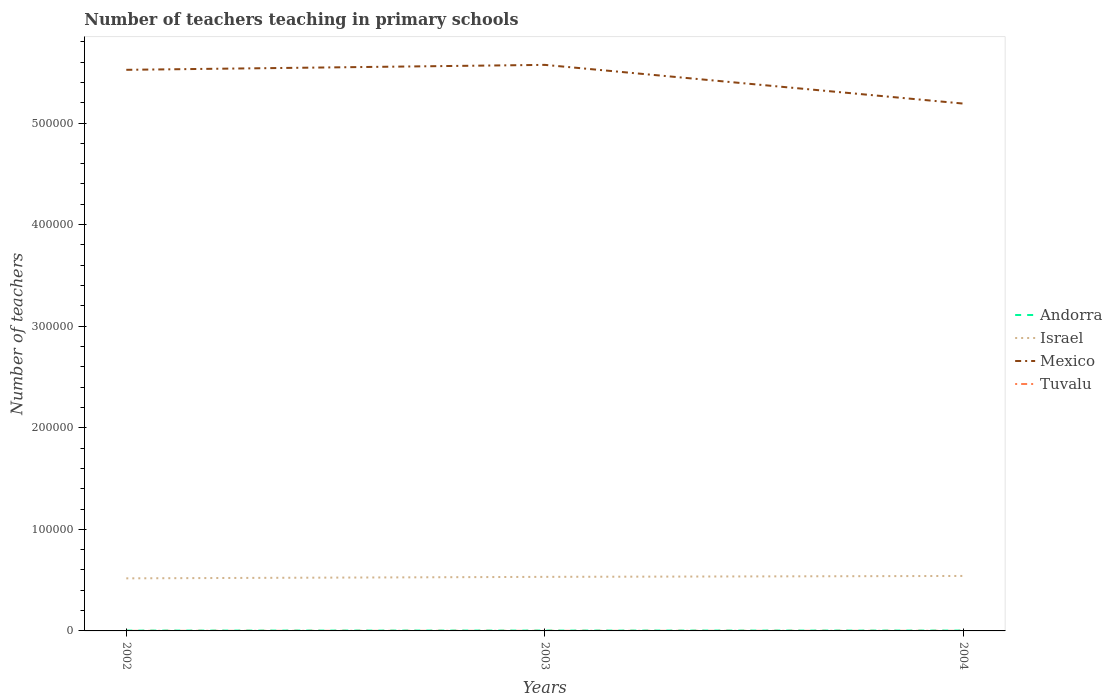How many different coloured lines are there?
Your response must be concise. 4. Is the number of lines equal to the number of legend labels?
Keep it short and to the point. Yes. Across all years, what is the maximum number of teachers teaching in primary schools in Israel?
Ensure brevity in your answer.  5.18e+04. What is the total number of teachers teaching in primary schools in Israel in the graph?
Ensure brevity in your answer.  -2350. What is the difference between the highest and the lowest number of teachers teaching in primary schools in Tuvalu?
Give a very brief answer. 1. Is the number of teachers teaching in primary schools in Tuvalu strictly greater than the number of teachers teaching in primary schools in Israel over the years?
Make the answer very short. Yes. How many lines are there?
Your response must be concise. 4. How many years are there in the graph?
Provide a short and direct response. 3. What is the difference between two consecutive major ticks on the Y-axis?
Your answer should be compact. 1.00e+05. Where does the legend appear in the graph?
Ensure brevity in your answer.  Center right. What is the title of the graph?
Make the answer very short. Number of teachers teaching in primary schools. What is the label or title of the Y-axis?
Provide a short and direct response. Number of teachers. What is the Number of teachers of Andorra in 2002?
Your answer should be very brief. 324. What is the Number of teachers in Israel in 2002?
Keep it short and to the point. 5.18e+04. What is the Number of teachers of Mexico in 2002?
Provide a short and direct response. 5.52e+05. What is the Number of teachers of Tuvalu in 2002?
Your response must be concise. 77. What is the Number of teachers in Andorra in 2003?
Provide a succinct answer. 343. What is the Number of teachers in Israel in 2003?
Offer a very short reply. 5.32e+04. What is the Number of teachers of Mexico in 2003?
Ensure brevity in your answer.  5.57e+05. What is the Number of teachers of Tuvalu in 2003?
Offer a terse response. 75. What is the Number of teachers of Andorra in 2004?
Offer a very short reply. 337. What is the Number of teachers in Israel in 2004?
Keep it short and to the point. 5.41e+04. What is the Number of teachers in Mexico in 2004?
Offer a very short reply. 5.19e+05. What is the Number of teachers of Tuvalu in 2004?
Give a very brief answer. 73. Across all years, what is the maximum Number of teachers of Andorra?
Offer a terse response. 343. Across all years, what is the maximum Number of teachers of Israel?
Give a very brief answer. 5.41e+04. Across all years, what is the maximum Number of teachers of Mexico?
Make the answer very short. 5.57e+05. Across all years, what is the maximum Number of teachers in Tuvalu?
Your response must be concise. 77. Across all years, what is the minimum Number of teachers in Andorra?
Make the answer very short. 324. Across all years, what is the minimum Number of teachers of Israel?
Provide a succinct answer. 5.18e+04. Across all years, what is the minimum Number of teachers in Mexico?
Ensure brevity in your answer.  5.19e+05. Across all years, what is the minimum Number of teachers in Tuvalu?
Provide a short and direct response. 73. What is the total Number of teachers of Andorra in the graph?
Keep it short and to the point. 1004. What is the total Number of teachers in Israel in the graph?
Provide a short and direct response. 1.59e+05. What is the total Number of teachers in Mexico in the graph?
Ensure brevity in your answer.  1.63e+06. What is the total Number of teachers in Tuvalu in the graph?
Give a very brief answer. 225. What is the difference between the Number of teachers in Andorra in 2002 and that in 2003?
Your response must be concise. -19. What is the difference between the Number of teachers of Israel in 2002 and that in 2003?
Give a very brief answer. -1453. What is the difference between the Number of teachers in Mexico in 2002 and that in 2003?
Provide a succinct answer. -4869. What is the difference between the Number of teachers of Tuvalu in 2002 and that in 2003?
Make the answer very short. 2. What is the difference between the Number of teachers of Andorra in 2002 and that in 2004?
Your response must be concise. -13. What is the difference between the Number of teachers in Israel in 2002 and that in 2004?
Your response must be concise. -2350. What is the difference between the Number of teachers in Mexico in 2002 and that in 2004?
Offer a terse response. 3.32e+04. What is the difference between the Number of teachers in Andorra in 2003 and that in 2004?
Your answer should be compact. 6. What is the difference between the Number of teachers in Israel in 2003 and that in 2004?
Your answer should be compact. -897. What is the difference between the Number of teachers in Mexico in 2003 and that in 2004?
Your answer should be very brief. 3.81e+04. What is the difference between the Number of teachers of Tuvalu in 2003 and that in 2004?
Make the answer very short. 2. What is the difference between the Number of teachers in Andorra in 2002 and the Number of teachers in Israel in 2003?
Make the answer very short. -5.29e+04. What is the difference between the Number of teachers of Andorra in 2002 and the Number of teachers of Mexico in 2003?
Give a very brief answer. -5.57e+05. What is the difference between the Number of teachers of Andorra in 2002 and the Number of teachers of Tuvalu in 2003?
Make the answer very short. 249. What is the difference between the Number of teachers in Israel in 2002 and the Number of teachers in Mexico in 2003?
Your response must be concise. -5.06e+05. What is the difference between the Number of teachers in Israel in 2002 and the Number of teachers in Tuvalu in 2003?
Offer a terse response. 5.17e+04. What is the difference between the Number of teachers of Mexico in 2002 and the Number of teachers of Tuvalu in 2003?
Make the answer very short. 5.52e+05. What is the difference between the Number of teachers in Andorra in 2002 and the Number of teachers in Israel in 2004?
Make the answer very short. -5.38e+04. What is the difference between the Number of teachers in Andorra in 2002 and the Number of teachers in Mexico in 2004?
Keep it short and to the point. -5.19e+05. What is the difference between the Number of teachers in Andorra in 2002 and the Number of teachers in Tuvalu in 2004?
Your answer should be very brief. 251. What is the difference between the Number of teachers in Israel in 2002 and the Number of teachers in Mexico in 2004?
Make the answer very short. -4.67e+05. What is the difference between the Number of teachers in Israel in 2002 and the Number of teachers in Tuvalu in 2004?
Make the answer very short. 5.17e+04. What is the difference between the Number of teachers of Mexico in 2002 and the Number of teachers of Tuvalu in 2004?
Ensure brevity in your answer.  5.52e+05. What is the difference between the Number of teachers of Andorra in 2003 and the Number of teachers of Israel in 2004?
Offer a terse response. -5.38e+04. What is the difference between the Number of teachers in Andorra in 2003 and the Number of teachers in Mexico in 2004?
Your answer should be very brief. -5.19e+05. What is the difference between the Number of teachers in Andorra in 2003 and the Number of teachers in Tuvalu in 2004?
Make the answer very short. 270. What is the difference between the Number of teachers in Israel in 2003 and the Number of teachers in Mexico in 2004?
Provide a short and direct response. -4.66e+05. What is the difference between the Number of teachers in Israel in 2003 and the Number of teachers in Tuvalu in 2004?
Give a very brief answer. 5.31e+04. What is the difference between the Number of teachers in Mexico in 2003 and the Number of teachers in Tuvalu in 2004?
Ensure brevity in your answer.  5.57e+05. What is the average Number of teachers in Andorra per year?
Make the answer very short. 334.67. What is the average Number of teachers in Israel per year?
Offer a very short reply. 5.30e+04. What is the average Number of teachers in Mexico per year?
Offer a very short reply. 5.43e+05. What is the average Number of teachers of Tuvalu per year?
Your answer should be compact. 75. In the year 2002, what is the difference between the Number of teachers in Andorra and Number of teachers in Israel?
Provide a short and direct response. -5.14e+04. In the year 2002, what is the difference between the Number of teachers of Andorra and Number of teachers of Mexico?
Ensure brevity in your answer.  -5.52e+05. In the year 2002, what is the difference between the Number of teachers in Andorra and Number of teachers in Tuvalu?
Your response must be concise. 247. In the year 2002, what is the difference between the Number of teachers in Israel and Number of teachers in Mexico?
Your answer should be compact. -5.01e+05. In the year 2002, what is the difference between the Number of teachers in Israel and Number of teachers in Tuvalu?
Offer a terse response. 5.17e+04. In the year 2002, what is the difference between the Number of teachers of Mexico and Number of teachers of Tuvalu?
Offer a very short reply. 5.52e+05. In the year 2003, what is the difference between the Number of teachers of Andorra and Number of teachers of Israel?
Ensure brevity in your answer.  -5.29e+04. In the year 2003, what is the difference between the Number of teachers in Andorra and Number of teachers in Mexico?
Keep it short and to the point. -5.57e+05. In the year 2003, what is the difference between the Number of teachers in Andorra and Number of teachers in Tuvalu?
Make the answer very short. 268. In the year 2003, what is the difference between the Number of teachers in Israel and Number of teachers in Mexico?
Provide a succinct answer. -5.04e+05. In the year 2003, what is the difference between the Number of teachers of Israel and Number of teachers of Tuvalu?
Keep it short and to the point. 5.31e+04. In the year 2003, what is the difference between the Number of teachers in Mexico and Number of teachers in Tuvalu?
Your answer should be very brief. 5.57e+05. In the year 2004, what is the difference between the Number of teachers of Andorra and Number of teachers of Israel?
Ensure brevity in your answer.  -5.38e+04. In the year 2004, what is the difference between the Number of teachers in Andorra and Number of teachers in Mexico?
Offer a terse response. -5.19e+05. In the year 2004, what is the difference between the Number of teachers of Andorra and Number of teachers of Tuvalu?
Ensure brevity in your answer.  264. In the year 2004, what is the difference between the Number of teachers in Israel and Number of teachers in Mexico?
Provide a short and direct response. -4.65e+05. In the year 2004, what is the difference between the Number of teachers in Israel and Number of teachers in Tuvalu?
Keep it short and to the point. 5.40e+04. In the year 2004, what is the difference between the Number of teachers of Mexico and Number of teachers of Tuvalu?
Your answer should be compact. 5.19e+05. What is the ratio of the Number of teachers of Andorra in 2002 to that in 2003?
Give a very brief answer. 0.94. What is the ratio of the Number of teachers of Israel in 2002 to that in 2003?
Your answer should be very brief. 0.97. What is the ratio of the Number of teachers of Mexico in 2002 to that in 2003?
Your answer should be compact. 0.99. What is the ratio of the Number of teachers in Tuvalu in 2002 to that in 2003?
Give a very brief answer. 1.03. What is the ratio of the Number of teachers of Andorra in 2002 to that in 2004?
Offer a terse response. 0.96. What is the ratio of the Number of teachers in Israel in 2002 to that in 2004?
Your answer should be compact. 0.96. What is the ratio of the Number of teachers of Mexico in 2002 to that in 2004?
Provide a succinct answer. 1.06. What is the ratio of the Number of teachers of Tuvalu in 2002 to that in 2004?
Provide a short and direct response. 1.05. What is the ratio of the Number of teachers of Andorra in 2003 to that in 2004?
Provide a short and direct response. 1.02. What is the ratio of the Number of teachers of Israel in 2003 to that in 2004?
Offer a very short reply. 0.98. What is the ratio of the Number of teachers of Mexico in 2003 to that in 2004?
Your response must be concise. 1.07. What is the ratio of the Number of teachers of Tuvalu in 2003 to that in 2004?
Provide a short and direct response. 1.03. What is the difference between the highest and the second highest Number of teachers of Israel?
Your answer should be compact. 897. What is the difference between the highest and the second highest Number of teachers in Mexico?
Make the answer very short. 4869. What is the difference between the highest and the second highest Number of teachers of Tuvalu?
Your response must be concise. 2. What is the difference between the highest and the lowest Number of teachers of Andorra?
Ensure brevity in your answer.  19. What is the difference between the highest and the lowest Number of teachers in Israel?
Ensure brevity in your answer.  2350. What is the difference between the highest and the lowest Number of teachers of Mexico?
Offer a terse response. 3.81e+04. 